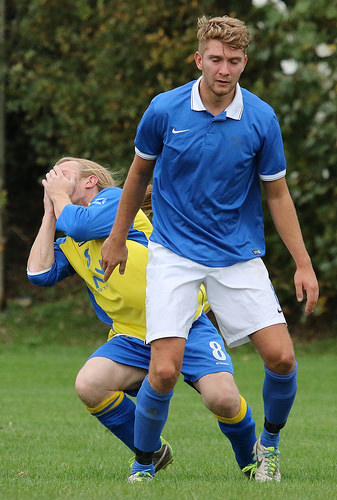<image>
Is the player to the left of the player? No. The player is not to the left of the player. From this viewpoint, they have a different horizontal relationship. 